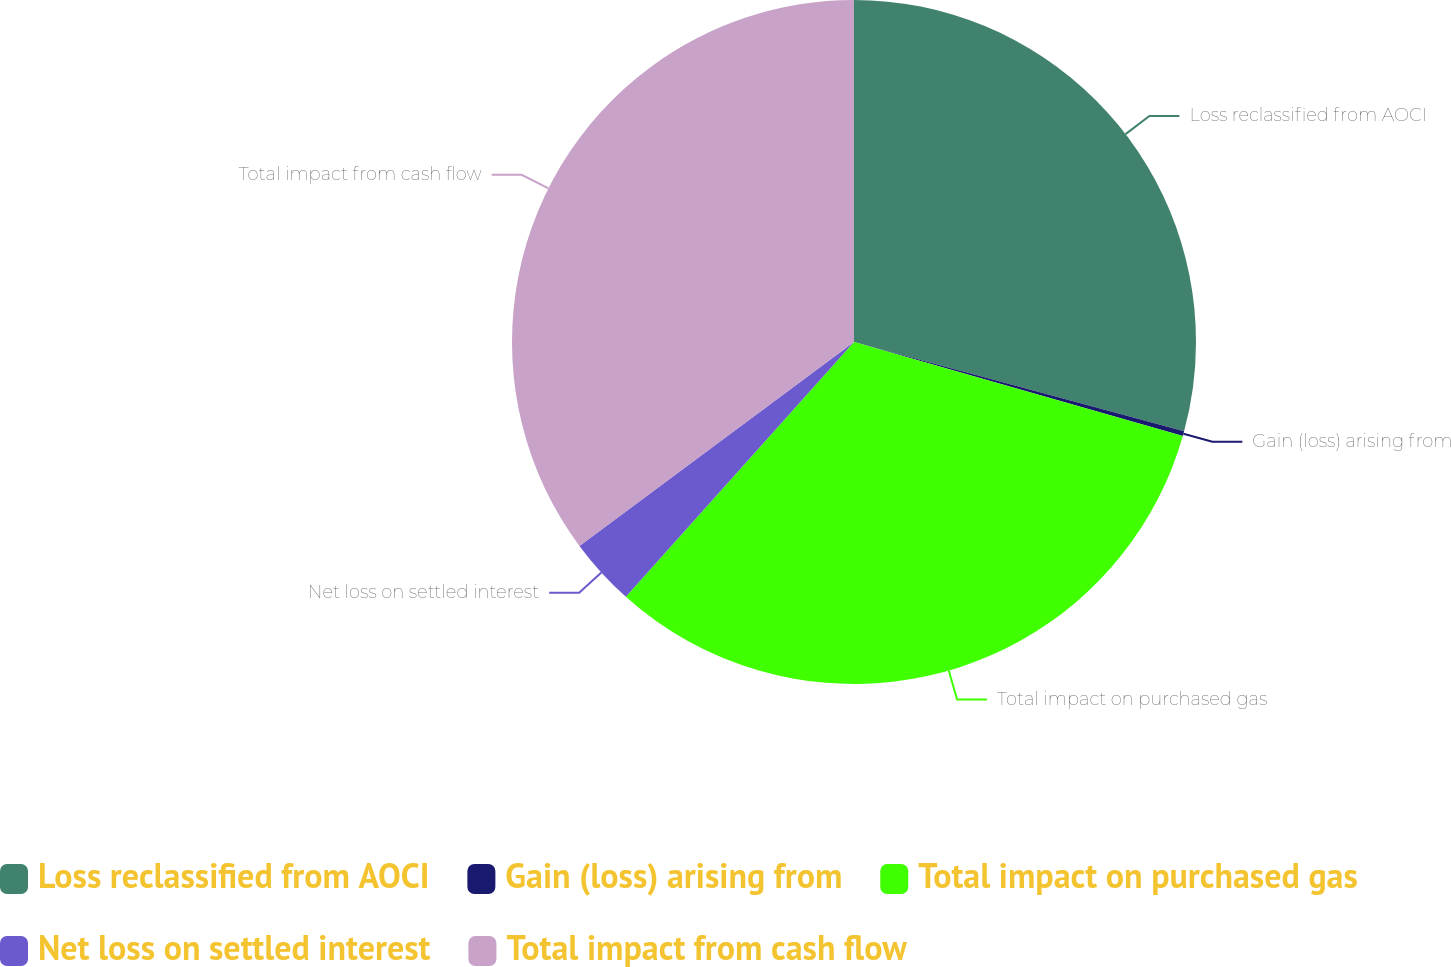Convert chart to OTSL. <chart><loc_0><loc_0><loc_500><loc_500><pie_chart><fcel>Loss reclassified from AOCI<fcel>Gain (loss) arising from<fcel>Total impact on purchased gas<fcel>Net loss on settled interest<fcel>Total impact from cash flow<nl><fcel>29.21%<fcel>0.23%<fcel>32.19%<fcel>3.21%<fcel>35.17%<nl></chart> 